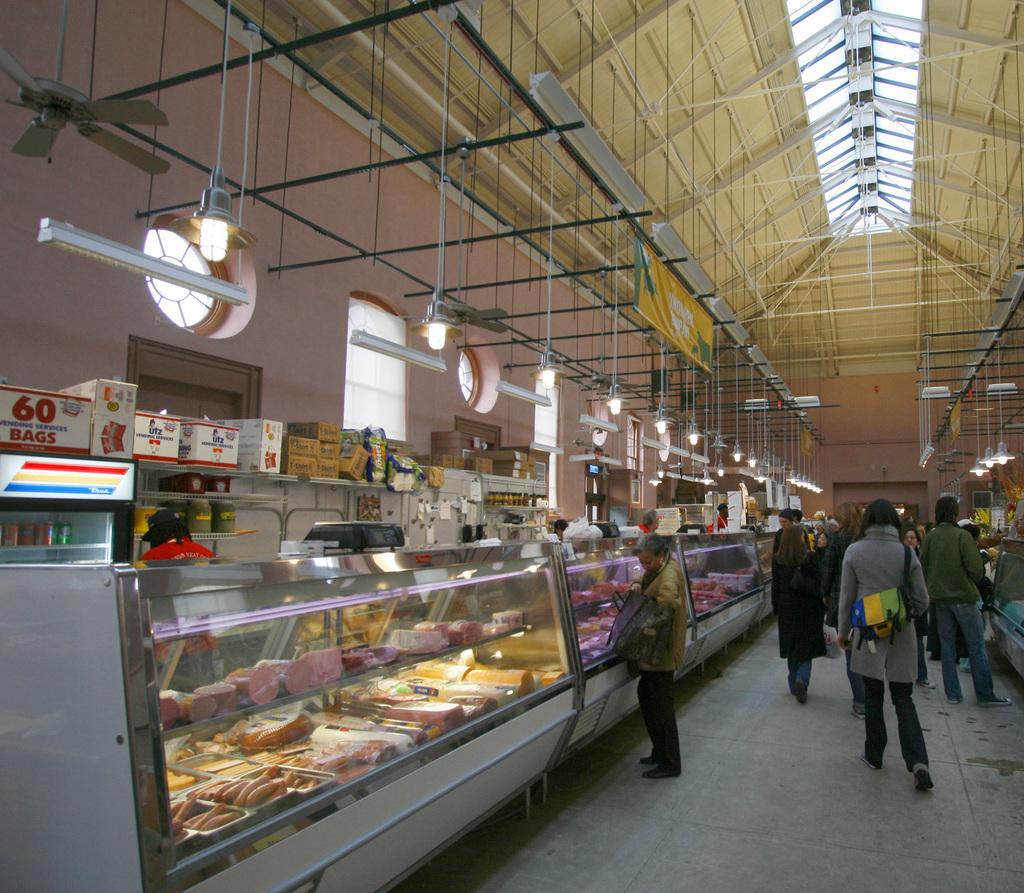How many bags are in the box on the far left?
Offer a terse response. 60. 